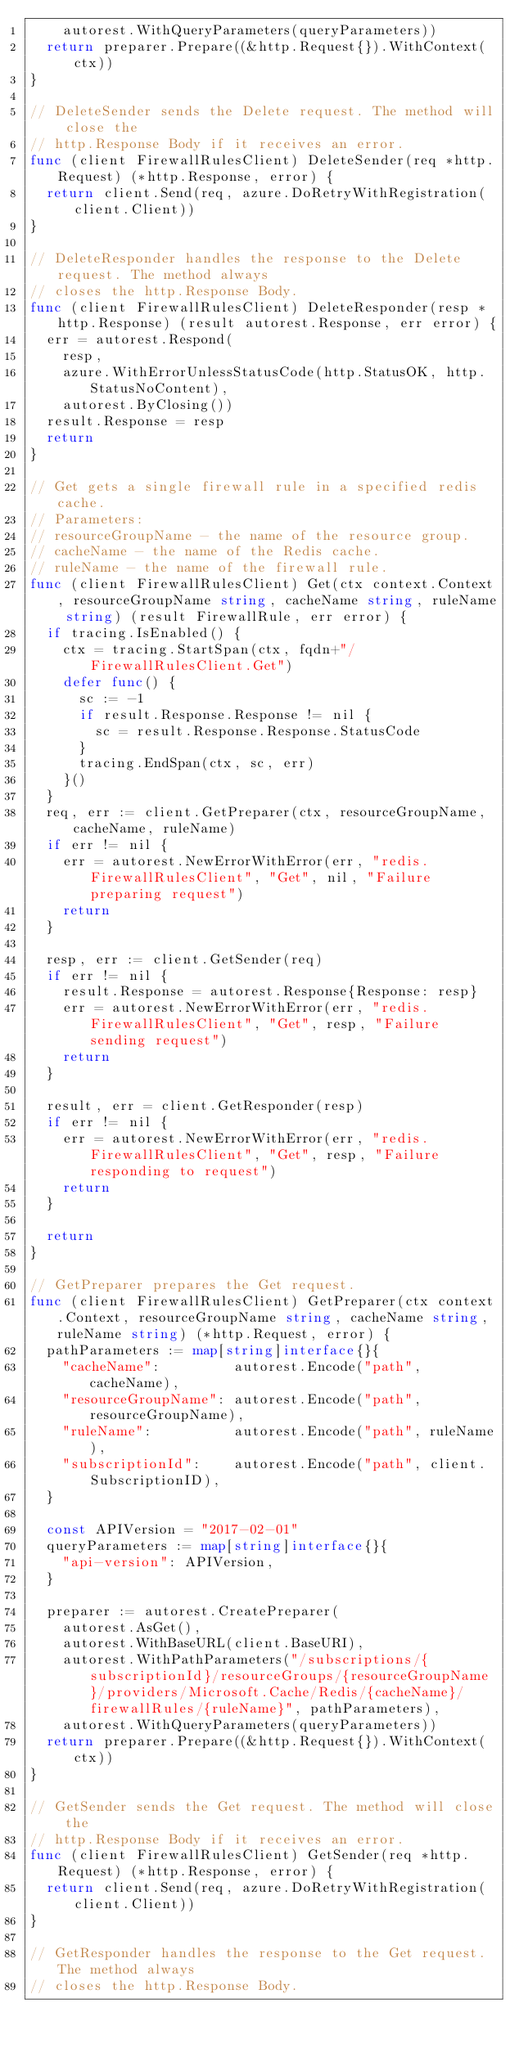Convert code to text. <code><loc_0><loc_0><loc_500><loc_500><_Go_>		autorest.WithQueryParameters(queryParameters))
	return preparer.Prepare((&http.Request{}).WithContext(ctx))
}

// DeleteSender sends the Delete request. The method will close the
// http.Response Body if it receives an error.
func (client FirewallRulesClient) DeleteSender(req *http.Request) (*http.Response, error) {
	return client.Send(req, azure.DoRetryWithRegistration(client.Client))
}

// DeleteResponder handles the response to the Delete request. The method always
// closes the http.Response Body.
func (client FirewallRulesClient) DeleteResponder(resp *http.Response) (result autorest.Response, err error) {
	err = autorest.Respond(
		resp,
		azure.WithErrorUnlessStatusCode(http.StatusOK, http.StatusNoContent),
		autorest.ByClosing())
	result.Response = resp
	return
}

// Get gets a single firewall rule in a specified redis cache.
// Parameters:
// resourceGroupName - the name of the resource group.
// cacheName - the name of the Redis cache.
// ruleName - the name of the firewall rule.
func (client FirewallRulesClient) Get(ctx context.Context, resourceGroupName string, cacheName string, ruleName string) (result FirewallRule, err error) {
	if tracing.IsEnabled() {
		ctx = tracing.StartSpan(ctx, fqdn+"/FirewallRulesClient.Get")
		defer func() {
			sc := -1
			if result.Response.Response != nil {
				sc = result.Response.Response.StatusCode
			}
			tracing.EndSpan(ctx, sc, err)
		}()
	}
	req, err := client.GetPreparer(ctx, resourceGroupName, cacheName, ruleName)
	if err != nil {
		err = autorest.NewErrorWithError(err, "redis.FirewallRulesClient", "Get", nil, "Failure preparing request")
		return
	}

	resp, err := client.GetSender(req)
	if err != nil {
		result.Response = autorest.Response{Response: resp}
		err = autorest.NewErrorWithError(err, "redis.FirewallRulesClient", "Get", resp, "Failure sending request")
		return
	}

	result, err = client.GetResponder(resp)
	if err != nil {
		err = autorest.NewErrorWithError(err, "redis.FirewallRulesClient", "Get", resp, "Failure responding to request")
		return
	}

	return
}

// GetPreparer prepares the Get request.
func (client FirewallRulesClient) GetPreparer(ctx context.Context, resourceGroupName string, cacheName string, ruleName string) (*http.Request, error) {
	pathParameters := map[string]interface{}{
		"cacheName":         autorest.Encode("path", cacheName),
		"resourceGroupName": autorest.Encode("path", resourceGroupName),
		"ruleName":          autorest.Encode("path", ruleName),
		"subscriptionId":    autorest.Encode("path", client.SubscriptionID),
	}

	const APIVersion = "2017-02-01"
	queryParameters := map[string]interface{}{
		"api-version": APIVersion,
	}

	preparer := autorest.CreatePreparer(
		autorest.AsGet(),
		autorest.WithBaseURL(client.BaseURI),
		autorest.WithPathParameters("/subscriptions/{subscriptionId}/resourceGroups/{resourceGroupName}/providers/Microsoft.Cache/Redis/{cacheName}/firewallRules/{ruleName}", pathParameters),
		autorest.WithQueryParameters(queryParameters))
	return preparer.Prepare((&http.Request{}).WithContext(ctx))
}

// GetSender sends the Get request. The method will close the
// http.Response Body if it receives an error.
func (client FirewallRulesClient) GetSender(req *http.Request) (*http.Response, error) {
	return client.Send(req, azure.DoRetryWithRegistration(client.Client))
}

// GetResponder handles the response to the Get request. The method always
// closes the http.Response Body.</code> 